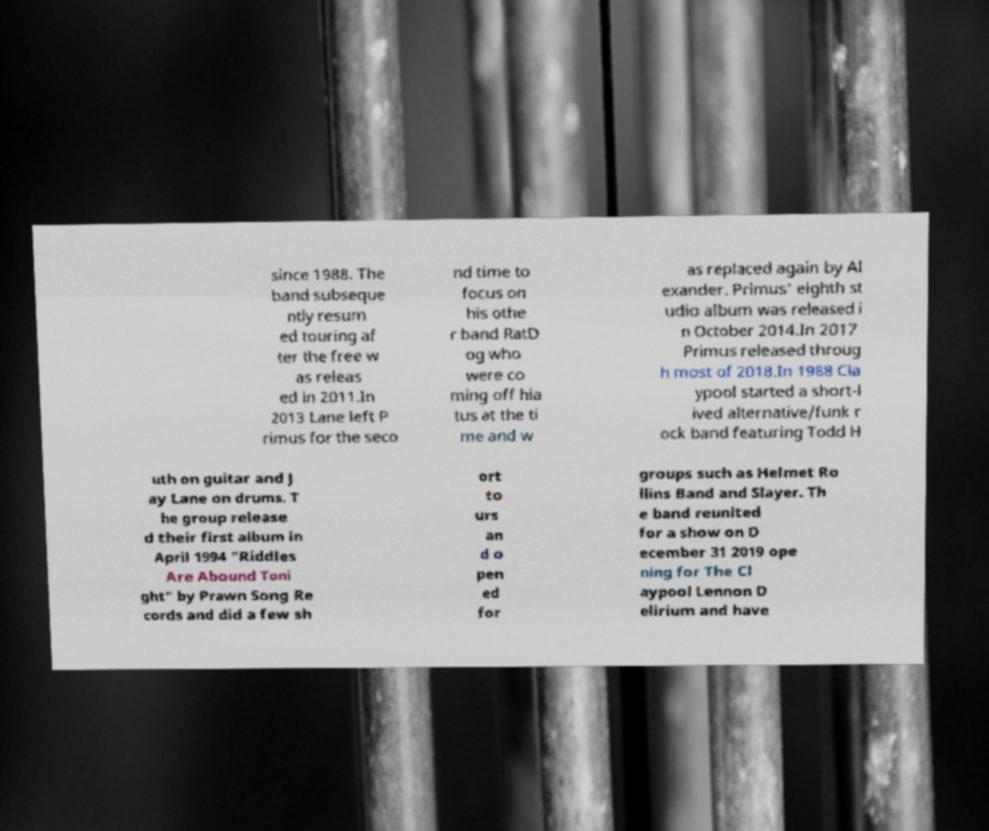Can you accurately transcribe the text from the provided image for me? since 1988. The band subseque ntly resum ed touring af ter the free w as releas ed in 2011.In 2013 Lane left P rimus for the seco nd time to focus on his othe r band RatD og who were co ming off hia tus at the ti me and w as replaced again by Al exander. Primus' eighth st udio album was released i n October 2014.In 2017 Primus released throug h most of 2018.In 1988 Cla ypool started a short-l ived alternative/funk r ock band featuring Todd H uth on guitar and J ay Lane on drums. T he group release d their first album in April 1994 "Riddles Are Abound Toni ght" by Prawn Song Re cords and did a few sh ort to urs an d o pen ed for groups such as Helmet Ro llins Band and Slayer. Th e band reunited for a show on D ecember 31 2019 ope ning for The Cl aypool Lennon D elirium and have 